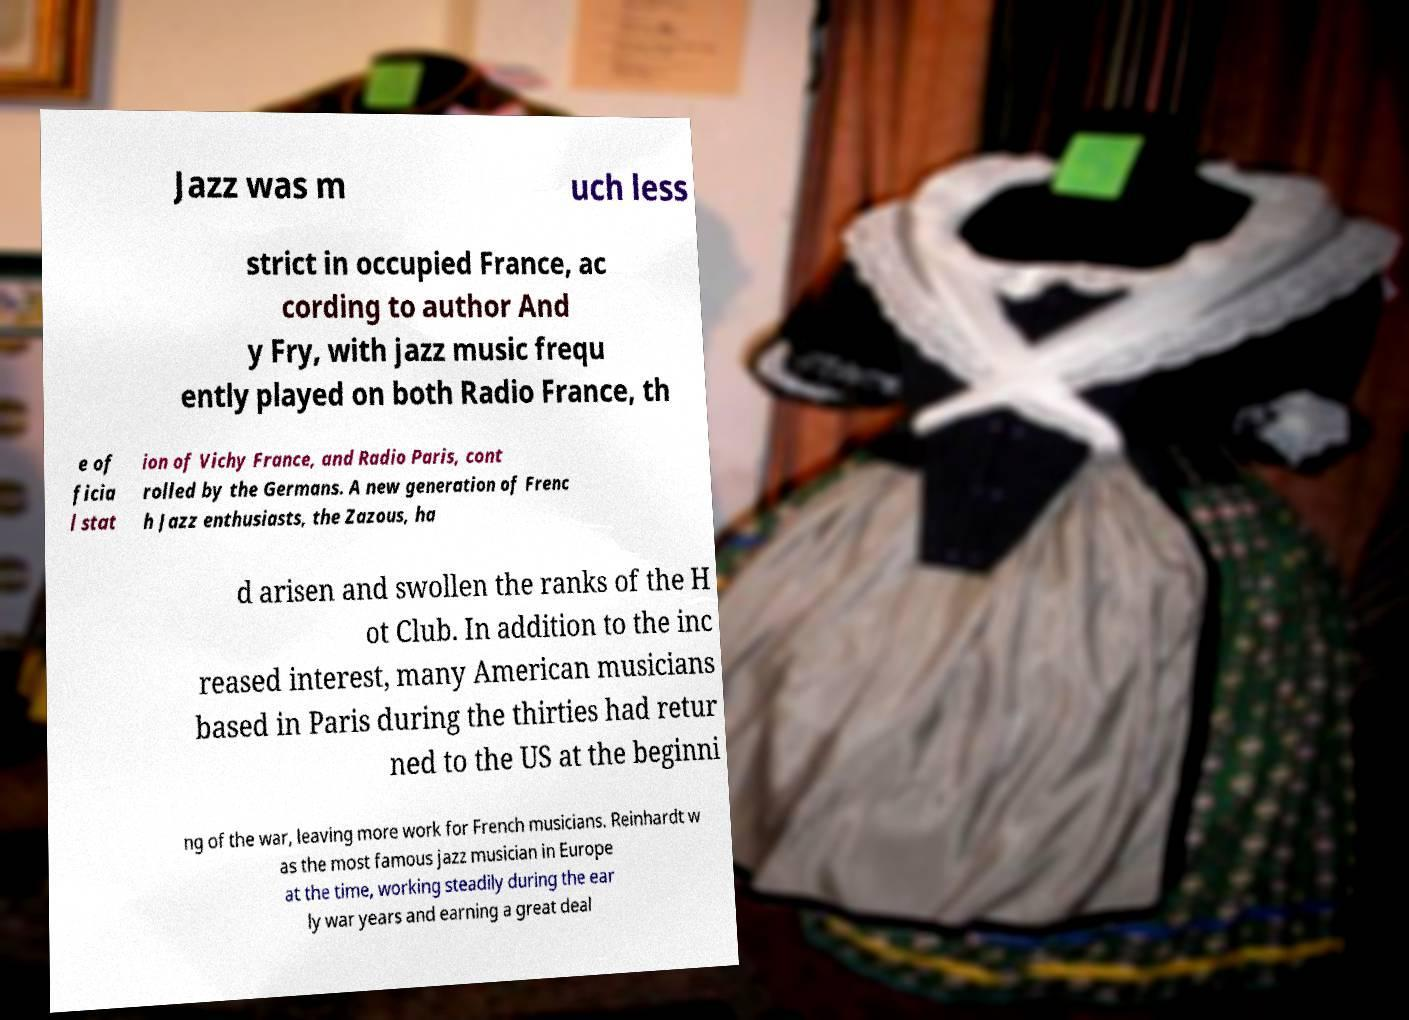Can you read and provide the text displayed in the image?This photo seems to have some interesting text. Can you extract and type it out for me? Jazz was m uch less strict in occupied France, ac cording to author And y Fry, with jazz music frequ ently played on both Radio France, th e of ficia l stat ion of Vichy France, and Radio Paris, cont rolled by the Germans. A new generation of Frenc h Jazz enthusiasts, the Zazous, ha d arisen and swollen the ranks of the H ot Club. In addition to the inc reased interest, many American musicians based in Paris during the thirties had retur ned to the US at the beginni ng of the war, leaving more work for French musicians. Reinhardt w as the most famous jazz musician in Europe at the time, working steadily during the ear ly war years and earning a great deal 